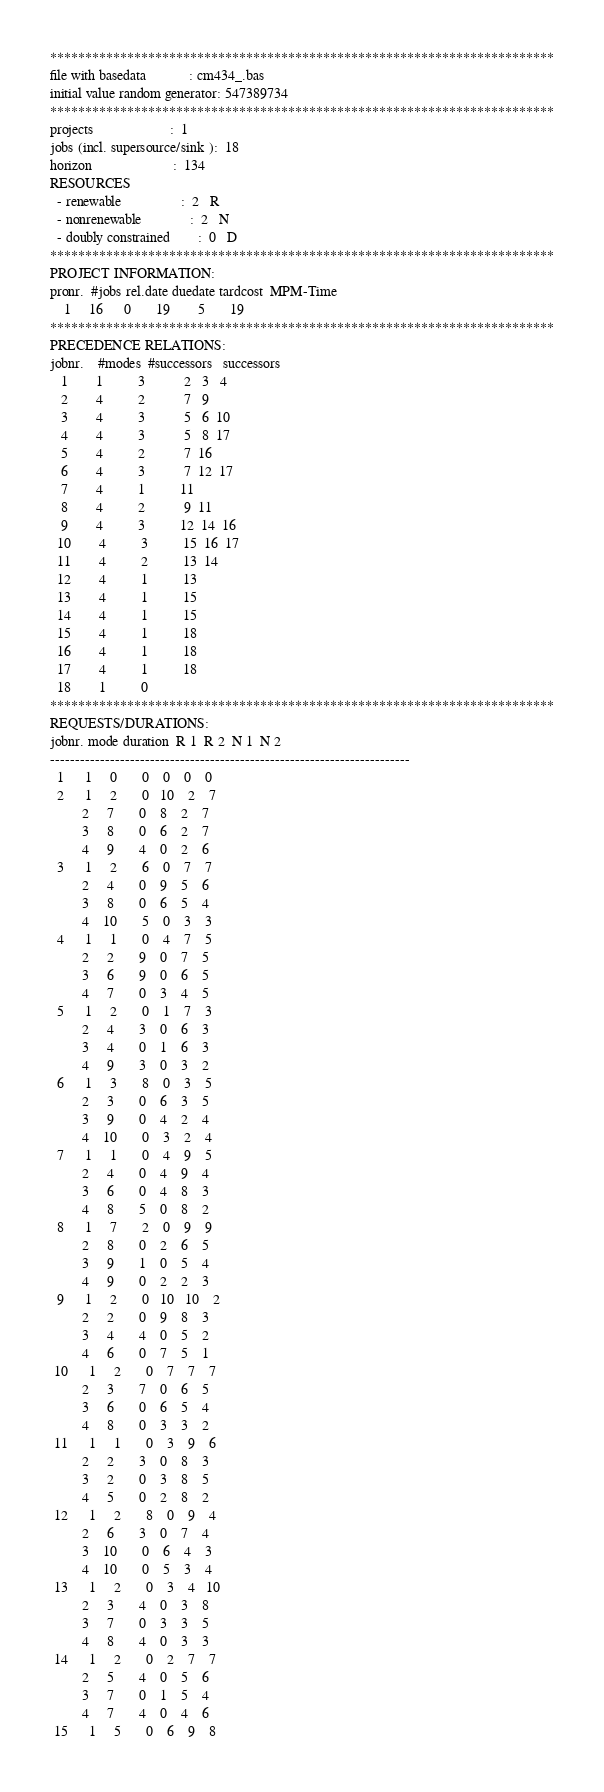Convert code to text. <code><loc_0><loc_0><loc_500><loc_500><_ObjectiveC_>************************************************************************
file with basedata            : cm434_.bas
initial value random generator: 547389734
************************************************************************
projects                      :  1
jobs (incl. supersource/sink ):  18
horizon                       :  134
RESOURCES
  - renewable                 :  2   R
  - nonrenewable              :  2   N
  - doubly constrained        :  0   D
************************************************************************
PROJECT INFORMATION:
pronr.  #jobs rel.date duedate tardcost  MPM-Time
    1     16      0       19        5       19
************************************************************************
PRECEDENCE RELATIONS:
jobnr.    #modes  #successors   successors
   1        1          3           2   3   4
   2        4          2           7   9
   3        4          3           5   6  10
   4        4          3           5   8  17
   5        4          2           7  16
   6        4          3           7  12  17
   7        4          1          11
   8        4          2           9  11
   9        4          3          12  14  16
  10        4          3          15  16  17
  11        4          2          13  14
  12        4          1          13
  13        4          1          15
  14        4          1          15
  15        4          1          18
  16        4          1          18
  17        4          1          18
  18        1          0        
************************************************************************
REQUESTS/DURATIONS:
jobnr. mode duration  R 1  R 2  N 1  N 2
------------------------------------------------------------------------
  1      1     0       0    0    0    0
  2      1     2       0   10    2    7
         2     7       0    8    2    7
         3     8       0    6    2    7
         4     9       4    0    2    6
  3      1     2       6    0    7    7
         2     4       0    9    5    6
         3     8       0    6    5    4
         4    10       5    0    3    3
  4      1     1       0    4    7    5
         2     2       9    0    7    5
         3     6       9    0    6    5
         4     7       0    3    4    5
  5      1     2       0    1    7    3
         2     4       3    0    6    3
         3     4       0    1    6    3
         4     9       3    0    3    2
  6      1     3       8    0    3    5
         2     3       0    6    3    5
         3     9       0    4    2    4
         4    10       0    3    2    4
  7      1     1       0    4    9    5
         2     4       0    4    9    4
         3     6       0    4    8    3
         4     8       5    0    8    2
  8      1     7       2    0    9    9
         2     8       0    2    6    5
         3     9       1    0    5    4
         4     9       0    2    2    3
  9      1     2       0   10   10    2
         2     2       0    9    8    3
         3     4       4    0    5    2
         4     6       0    7    5    1
 10      1     2       0    7    7    7
         2     3       7    0    6    5
         3     6       0    6    5    4
         4     8       0    3    3    2
 11      1     1       0    3    9    6
         2     2       3    0    8    3
         3     2       0    3    8    5
         4     5       0    2    8    2
 12      1     2       8    0    9    4
         2     6       3    0    7    4
         3    10       0    6    4    3
         4    10       0    5    3    4
 13      1     2       0    3    4   10
         2     3       4    0    3    8
         3     7       0    3    3    5
         4     8       4    0    3    3
 14      1     2       0    2    7    7
         2     5       4    0    5    6
         3     7       0    1    5    4
         4     7       4    0    4    6
 15      1     5       0    6    9    8</code> 